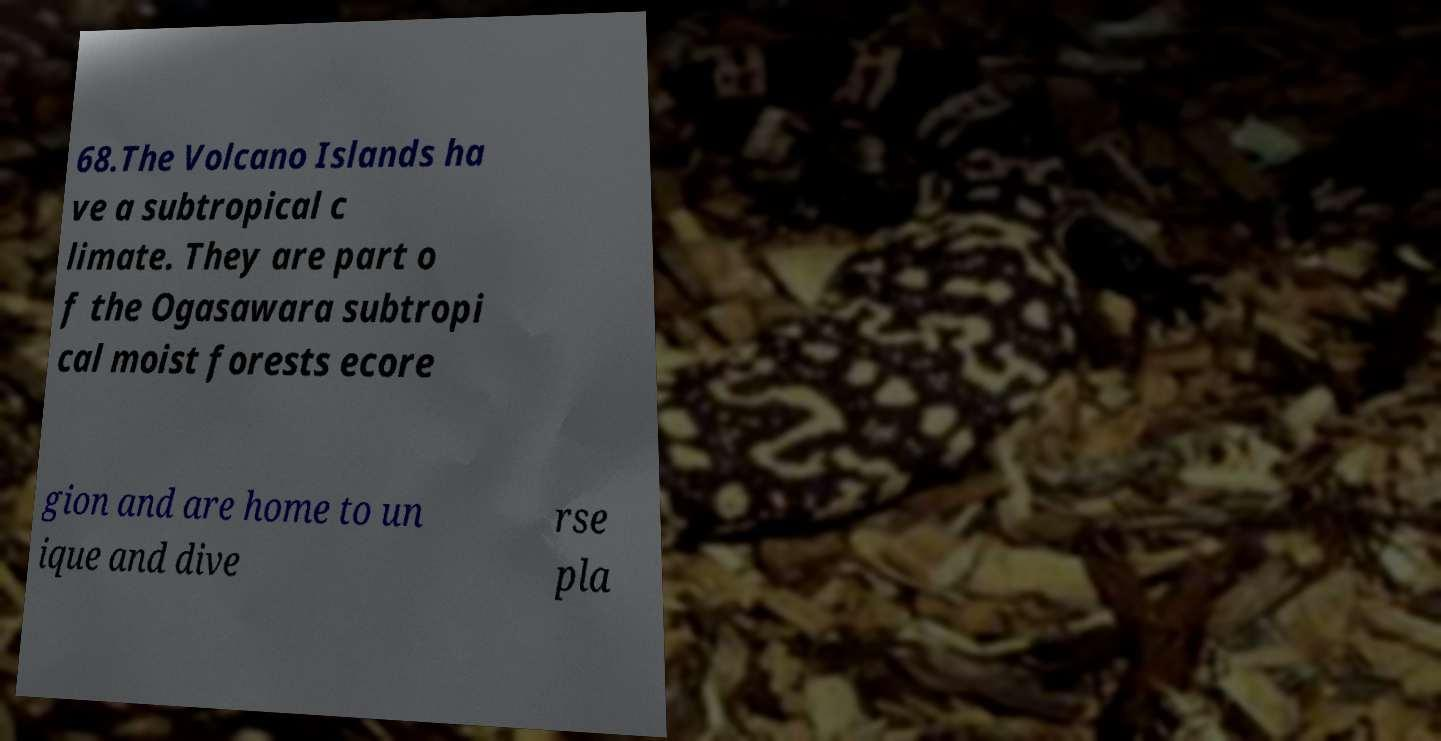There's text embedded in this image that I need extracted. Can you transcribe it verbatim? 68.The Volcano Islands ha ve a subtropical c limate. They are part o f the Ogasawara subtropi cal moist forests ecore gion and are home to un ique and dive rse pla 